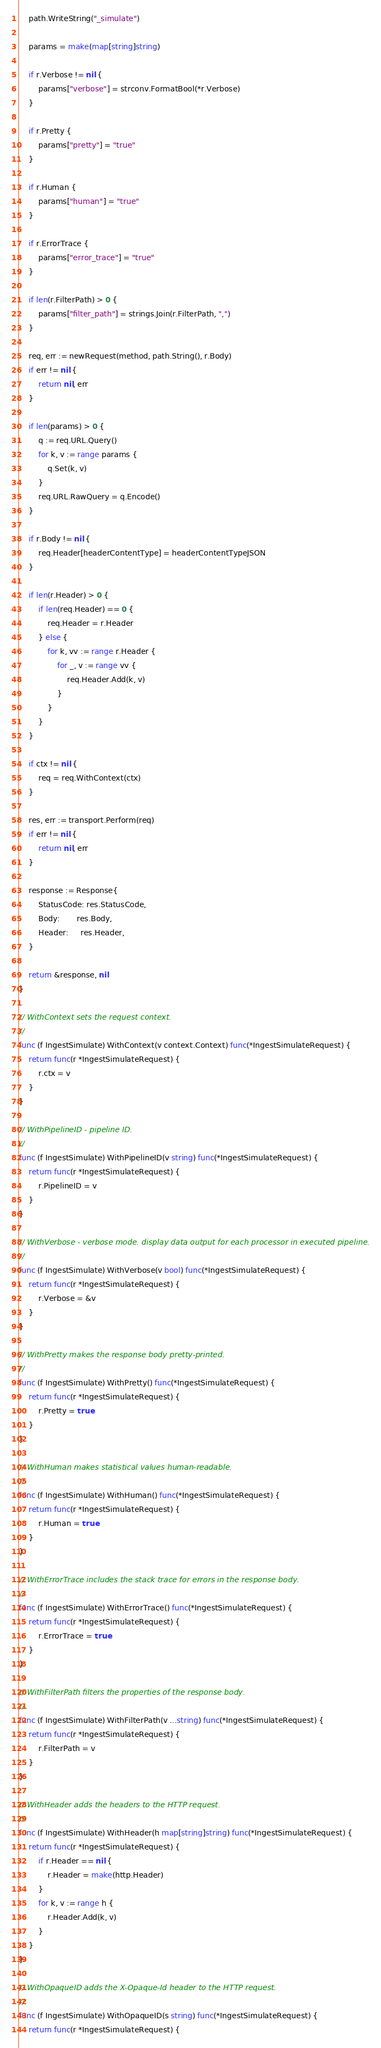Convert code to text. <code><loc_0><loc_0><loc_500><loc_500><_Go_>	path.WriteString("_simulate")

	params = make(map[string]string)

	if r.Verbose != nil {
		params["verbose"] = strconv.FormatBool(*r.Verbose)
	}

	if r.Pretty {
		params["pretty"] = "true"
	}

	if r.Human {
		params["human"] = "true"
	}

	if r.ErrorTrace {
		params["error_trace"] = "true"
	}

	if len(r.FilterPath) > 0 {
		params["filter_path"] = strings.Join(r.FilterPath, ",")
	}

	req, err := newRequest(method, path.String(), r.Body)
	if err != nil {
		return nil, err
	}

	if len(params) > 0 {
		q := req.URL.Query()
		for k, v := range params {
			q.Set(k, v)
		}
		req.URL.RawQuery = q.Encode()
	}

	if r.Body != nil {
		req.Header[headerContentType] = headerContentTypeJSON
	}

	if len(r.Header) > 0 {
		if len(req.Header) == 0 {
			req.Header = r.Header
		} else {
			for k, vv := range r.Header {
				for _, v := range vv {
					req.Header.Add(k, v)
				}
			}
		}
	}

	if ctx != nil {
		req = req.WithContext(ctx)
	}

	res, err := transport.Perform(req)
	if err != nil {
		return nil, err
	}

	response := Response{
		StatusCode: res.StatusCode,
		Body:       res.Body,
		Header:     res.Header,
	}

	return &response, nil
}

// WithContext sets the request context.
//
func (f IngestSimulate) WithContext(v context.Context) func(*IngestSimulateRequest) {
	return func(r *IngestSimulateRequest) {
		r.ctx = v
	}
}

// WithPipelineID - pipeline ID.
//
func (f IngestSimulate) WithPipelineID(v string) func(*IngestSimulateRequest) {
	return func(r *IngestSimulateRequest) {
		r.PipelineID = v
	}
}

// WithVerbose - verbose mode. display data output for each processor in executed pipeline.
//
func (f IngestSimulate) WithVerbose(v bool) func(*IngestSimulateRequest) {
	return func(r *IngestSimulateRequest) {
		r.Verbose = &v
	}
}

// WithPretty makes the response body pretty-printed.
//
func (f IngestSimulate) WithPretty() func(*IngestSimulateRequest) {
	return func(r *IngestSimulateRequest) {
		r.Pretty = true
	}
}

// WithHuman makes statistical values human-readable.
//
func (f IngestSimulate) WithHuman() func(*IngestSimulateRequest) {
	return func(r *IngestSimulateRequest) {
		r.Human = true
	}
}

// WithErrorTrace includes the stack trace for errors in the response body.
//
func (f IngestSimulate) WithErrorTrace() func(*IngestSimulateRequest) {
	return func(r *IngestSimulateRequest) {
		r.ErrorTrace = true
	}
}

// WithFilterPath filters the properties of the response body.
//
func (f IngestSimulate) WithFilterPath(v ...string) func(*IngestSimulateRequest) {
	return func(r *IngestSimulateRequest) {
		r.FilterPath = v
	}
}

// WithHeader adds the headers to the HTTP request.
//
func (f IngestSimulate) WithHeader(h map[string]string) func(*IngestSimulateRequest) {
	return func(r *IngestSimulateRequest) {
		if r.Header == nil {
			r.Header = make(http.Header)
		}
		for k, v := range h {
			r.Header.Add(k, v)
		}
	}
}

// WithOpaqueID adds the X-Opaque-Id header to the HTTP request.
//
func (f IngestSimulate) WithOpaqueID(s string) func(*IngestSimulateRequest) {
	return func(r *IngestSimulateRequest) {</code> 